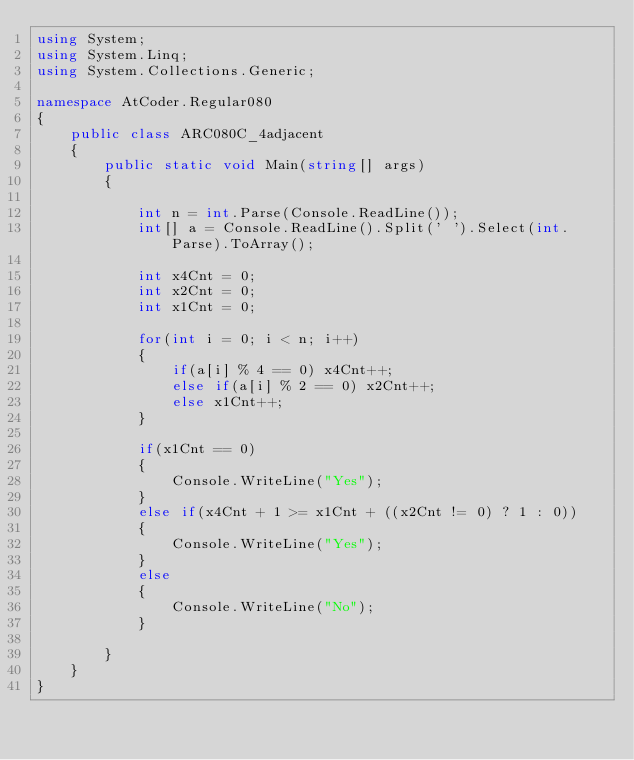Convert code to text. <code><loc_0><loc_0><loc_500><loc_500><_C#_>using System;
using System.Linq;
using System.Collections.Generic;

namespace AtCoder.Regular080
{
    public class ARC080C_4adjacent
    {
        public static void Main(string[] args)
        {
            
            int n = int.Parse(Console.ReadLine());
            int[] a = Console.ReadLine().Split(' ').Select(int.Parse).ToArray();

            int x4Cnt = 0;
            int x2Cnt = 0;
            int x1Cnt = 0;

            for(int i = 0; i < n; i++)
            {
                if(a[i] % 4 == 0) x4Cnt++;
                else if(a[i] % 2 == 0) x2Cnt++;
                else x1Cnt++;
            }

            if(x1Cnt == 0)
            {
                Console.WriteLine("Yes");
            }
            else if(x4Cnt + 1 >= x1Cnt + ((x2Cnt != 0) ? 1 : 0))
            {
                Console.WriteLine("Yes");
            }
            else
            {
                Console.WriteLine("No");
            }
            
        }
    }
}</code> 